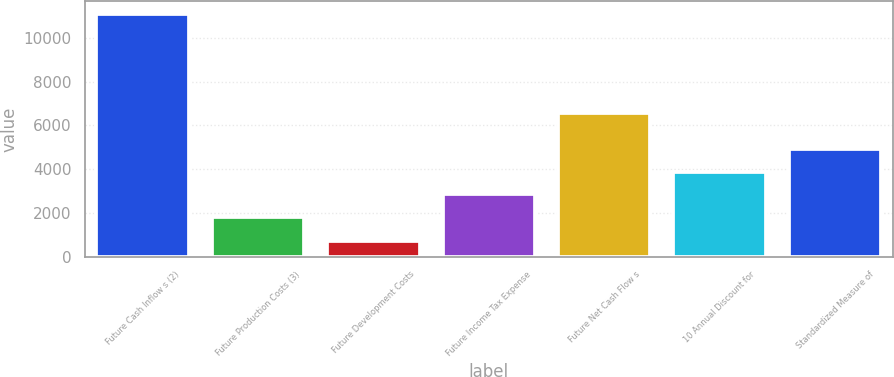Convert chart. <chart><loc_0><loc_0><loc_500><loc_500><bar_chart><fcel>Future Cash Inflow s (2)<fcel>Future Production Costs (3)<fcel>Future Development Costs<fcel>Future Income Tax Expense<fcel>Future Net Cash Flow s<fcel>10 Annual Discount for<fcel>Standardized Measure of<nl><fcel>11112<fcel>1808<fcel>716<fcel>2847.6<fcel>6560<fcel>3887.2<fcel>4926.8<nl></chart> 